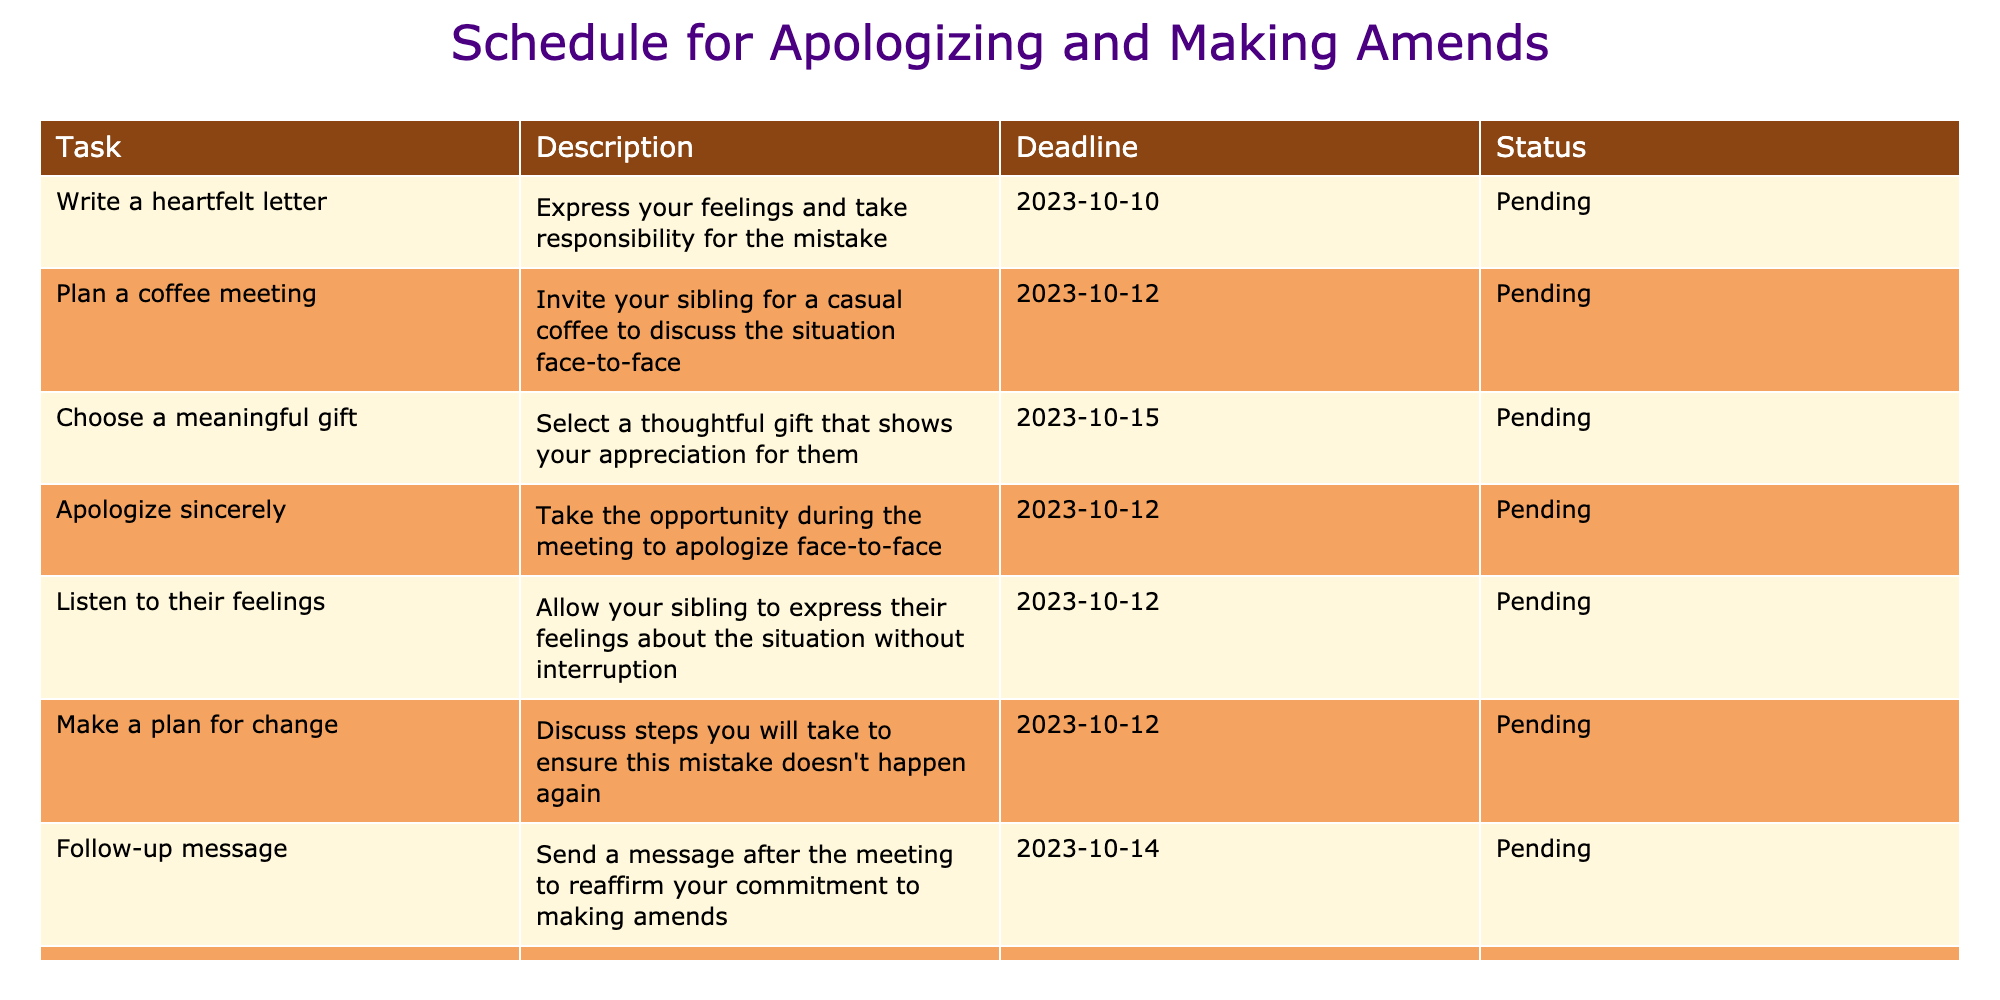What is the deadline for writing a heartfelt letter? The table shows that the deadline for writing a heartfelt letter is listed under the "Deadline" column for this task, which is 2023-10-10.
Answer: 2023-10-10 How many tasks have a deadline on or before October 12, 2023? By checking the deadlines in the table, the tasks with deadlines on or before October 12, 2023, are "Write a heartfelt letter" (2023-10-10), "Plan a coffee meeting" (2023-10-12), "Apologize sincerely" (2023-10-12), and "Listen to their feelings" (2023-10-12). This totals to four tasks.
Answer: 4 Is there a task scheduled for October 15, 2023? The table indicates that there is one task, which is "Choose a meaningful gift," that falls on the date of October 15, 2023. Therefore, the answer is yes.
Answer: Yes What is the status of the task "Make a plan for change"? According to the table, the status listed for the task "Make a plan for change" is "Pending."
Answer: Pending Which tasks have the earliest deadline, and what is that date? Reviewing the deadlines, the earliest date is 2023-10-10 from the task "Write a heartfelt letter." There are three other tasks with the same earliest deadline (October 12): "Plan a coffee meeting," "Apologize sincerely," and "Listen to their feelings." Therefore, the earliest deadline is 2023-10-10.
Answer: 2023-10-10 If you plan to send a follow-up message, which date would you complete this task? The table shows that the follow-up message task is scheduled for 2023-10-14. Therefore, this is the date when the follow-up message would be completed.
Answer: 2023-10-14 How many tasks are pending and how many tasks are completed? All eight tasks listed have the status of "Pending." Since there are no completed tasks—meaning zero tasks have a status of "Completed"—there are eight pending tasks and zero completed tasks.
Answer: 8 Pending, 0 Completed Which two tasks are scheduled for the same day, October 12, 2023? The tasks that are both scheduled for October 12, 2023, are "Plan a coffee meeting" and "Listen to their feelings." Therefore, these two tasks are scheduled for the same day.
Answer: "Plan a coffee meeting" and "Listen to their feelings" 